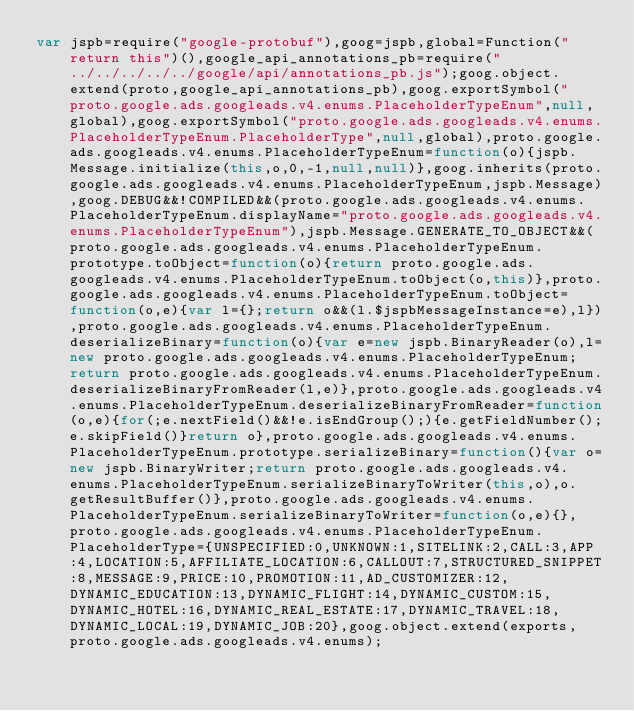<code> <loc_0><loc_0><loc_500><loc_500><_JavaScript_>var jspb=require("google-protobuf"),goog=jspb,global=Function("return this")(),google_api_annotations_pb=require("../../../../../google/api/annotations_pb.js");goog.object.extend(proto,google_api_annotations_pb),goog.exportSymbol("proto.google.ads.googleads.v4.enums.PlaceholderTypeEnum",null,global),goog.exportSymbol("proto.google.ads.googleads.v4.enums.PlaceholderTypeEnum.PlaceholderType",null,global),proto.google.ads.googleads.v4.enums.PlaceholderTypeEnum=function(o){jspb.Message.initialize(this,o,0,-1,null,null)},goog.inherits(proto.google.ads.googleads.v4.enums.PlaceholderTypeEnum,jspb.Message),goog.DEBUG&&!COMPILED&&(proto.google.ads.googleads.v4.enums.PlaceholderTypeEnum.displayName="proto.google.ads.googleads.v4.enums.PlaceholderTypeEnum"),jspb.Message.GENERATE_TO_OBJECT&&(proto.google.ads.googleads.v4.enums.PlaceholderTypeEnum.prototype.toObject=function(o){return proto.google.ads.googleads.v4.enums.PlaceholderTypeEnum.toObject(o,this)},proto.google.ads.googleads.v4.enums.PlaceholderTypeEnum.toObject=function(o,e){var l={};return o&&(l.$jspbMessageInstance=e),l}),proto.google.ads.googleads.v4.enums.PlaceholderTypeEnum.deserializeBinary=function(o){var e=new jspb.BinaryReader(o),l=new proto.google.ads.googleads.v4.enums.PlaceholderTypeEnum;return proto.google.ads.googleads.v4.enums.PlaceholderTypeEnum.deserializeBinaryFromReader(l,e)},proto.google.ads.googleads.v4.enums.PlaceholderTypeEnum.deserializeBinaryFromReader=function(o,e){for(;e.nextField()&&!e.isEndGroup();){e.getFieldNumber();e.skipField()}return o},proto.google.ads.googleads.v4.enums.PlaceholderTypeEnum.prototype.serializeBinary=function(){var o=new jspb.BinaryWriter;return proto.google.ads.googleads.v4.enums.PlaceholderTypeEnum.serializeBinaryToWriter(this,o),o.getResultBuffer()},proto.google.ads.googleads.v4.enums.PlaceholderTypeEnum.serializeBinaryToWriter=function(o,e){},proto.google.ads.googleads.v4.enums.PlaceholderTypeEnum.PlaceholderType={UNSPECIFIED:0,UNKNOWN:1,SITELINK:2,CALL:3,APP:4,LOCATION:5,AFFILIATE_LOCATION:6,CALLOUT:7,STRUCTURED_SNIPPET:8,MESSAGE:9,PRICE:10,PROMOTION:11,AD_CUSTOMIZER:12,DYNAMIC_EDUCATION:13,DYNAMIC_FLIGHT:14,DYNAMIC_CUSTOM:15,DYNAMIC_HOTEL:16,DYNAMIC_REAL_ESTATE:17,DYNAMIC_TRAVEL:18,DYNAMIC_LOCAL:19,DYNAMIC_JOB:20},goog.object.extend(exports,proto.google.ads.googleads.v4.enums);</code> 